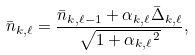Convert formula to latex. <formula><loc_0><loc_0><loc_500><loc_500>\bar { n } _ { k , \ell } = \frac { \bar { n } _ { k , \ell - 1 } + \alpha _ { k , \ell } \bar { \Delta } _ { k , \ell } } { \sqrt { 1 + { \alpha _ { k , \ell } } ^ { 2 } } } ,</formula> 